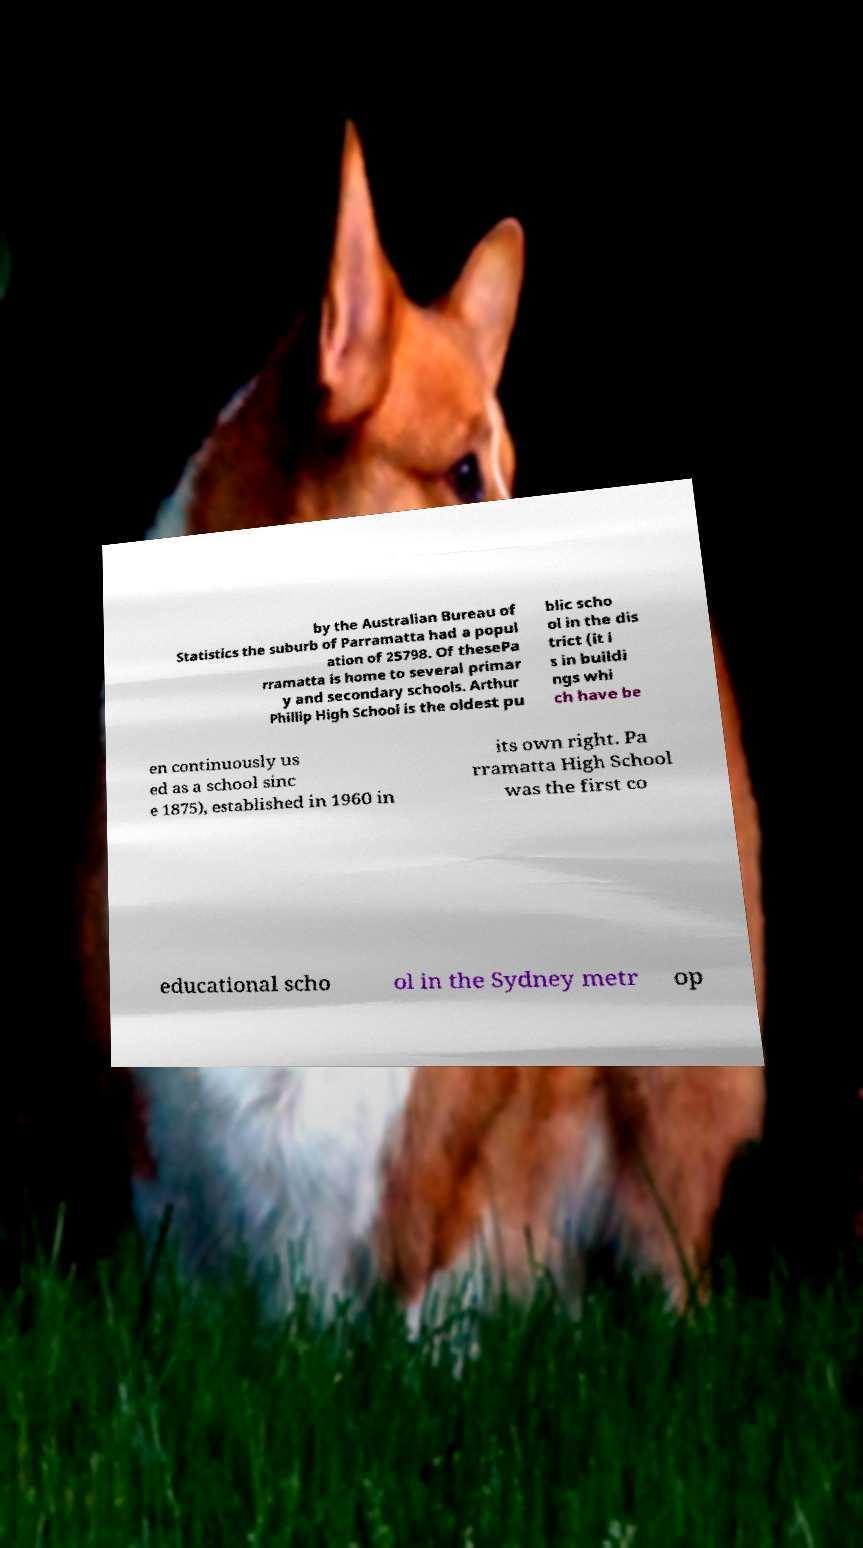Can you read and provide the text displayed in the image?This photo seems to have some interesting text. Can you extract and type it out for me? by the Australian Bureau of Statistics the suburb of Parramatta had a popul ation of 25798. Of thesePa rramatta is home to several primar y and secondary schools. Arthur Phillip High School is the oldest pu blic scho ol in the dis trict (it i s in buildi ngs whi ch have be en continuously us ed as a school sinc e 1875), established in 1960 in its own right. Pa rramatta High School was the first co educational scho ol in the Sydney metr op 